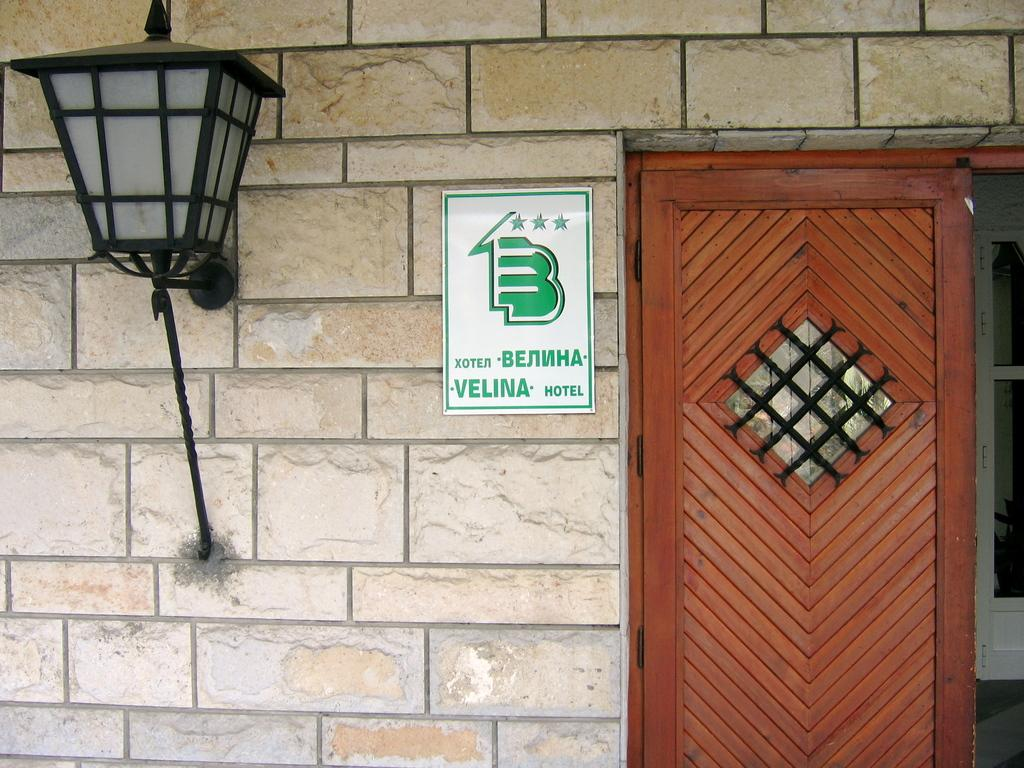What type of structure can be seen in the image? There is a wall in the image. What is attached to the wall in the image? There is a board with an image and text in the image. What can provide illumination in the image? There is a light in the image. Is there a way to enter or exit the space in the image? Yes, there is a door in the image. Where is the playground located in the image? There is no playground present in the image. Who is the guide in the image? There is no guide present in the image. 